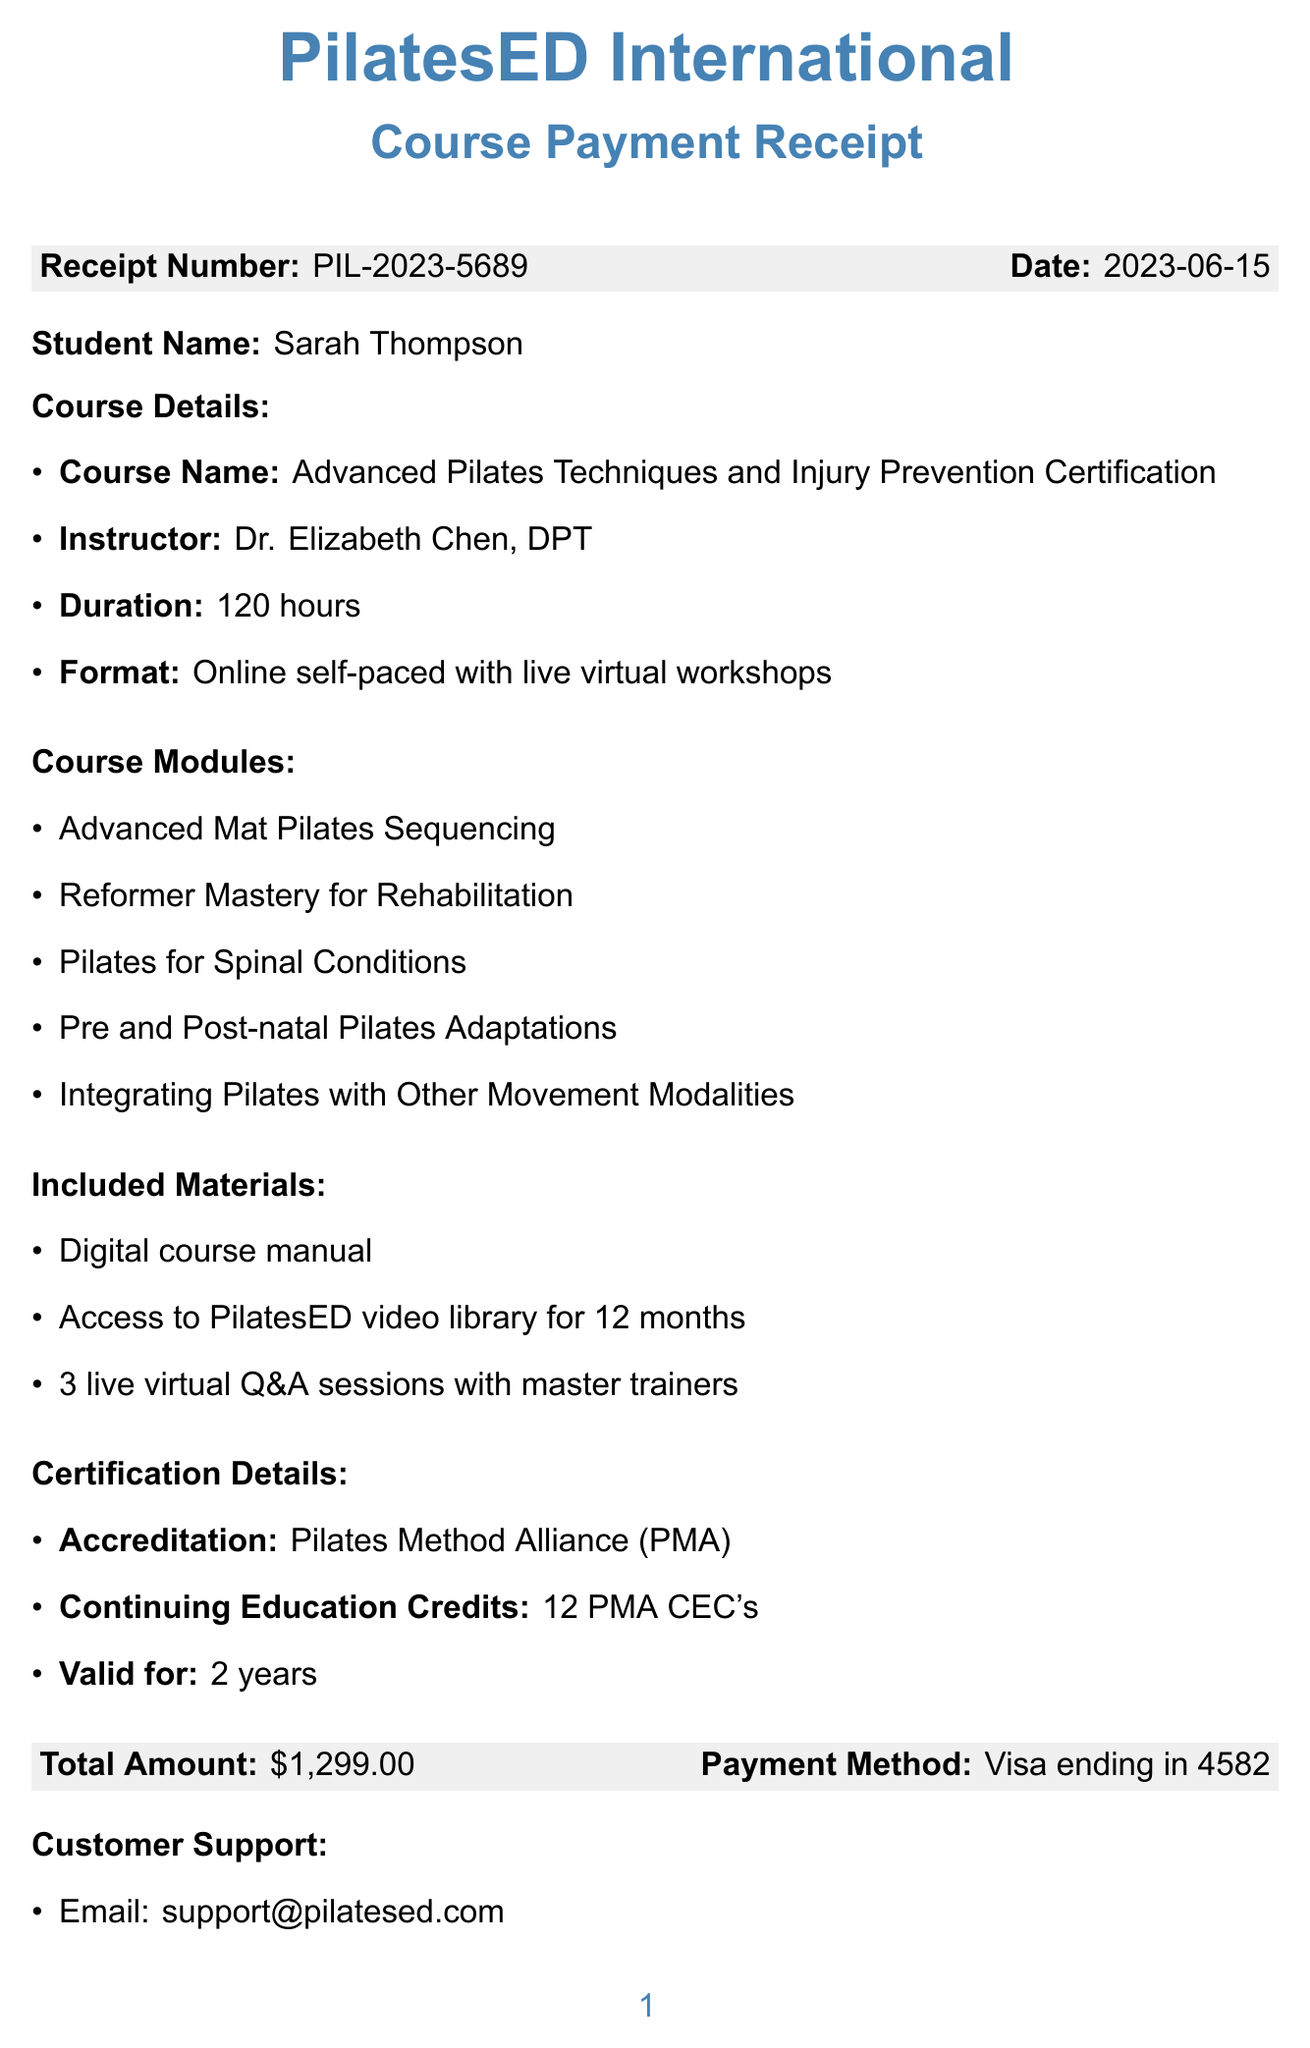What is the receipt number? The receipt number is a unique identifier for the purchase and is noted in the document.
Answer: PIL-2023-5689 Who is the instructor for the course? The instructor's name is mentioned as part of the course details.
Answer: Dr. Elizabeth Chen, DPT What is the total amount paid for the course? The total amount is stated clearly in the document and reflects the cost of the course.
Answer: $1,299.00 How many continuing education credits does this certification provide? The number of continuing education credits is specified under certification details.
Answer: 12 PMA CEC's What is the duration of the course? The duration is provided in hours as part of the course details.
Answer: 120 hours What is the refund policy for the course? The refund policy outlines the conditions under which a refund can be obtained.
Answer: 14-day money-back guarantee, subject to terms and conditions What materials are included with the course? The included materials are listed explicitly in the document, detailing what students will receive.
Answer: Digital course manual, Access to PilatesED video library for 12 months, 3 live virtual Q&A sessions with master trainers How long is the access to the video library valid? The length of access is a crucial detail for accessing course materials and is mentioned explicitly.
Answer: 12 months What accreditation does this certification hold? The document specifies the accreditation associated with the certification program.
Answer: Pilates Method Alliance (PMA) 